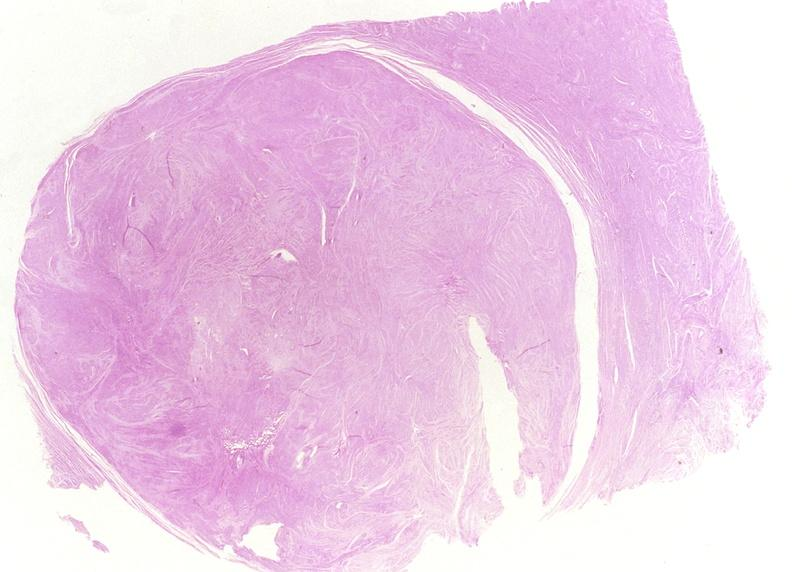what is present?
Answer the question using a single word or phrase. Female reproductive 